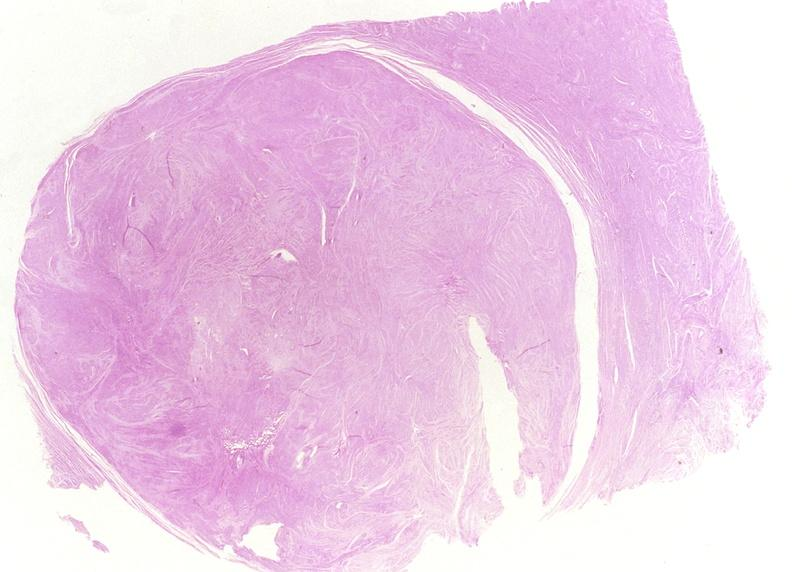what is present?
Answer the question using a single word or phrase. Female reproductive 